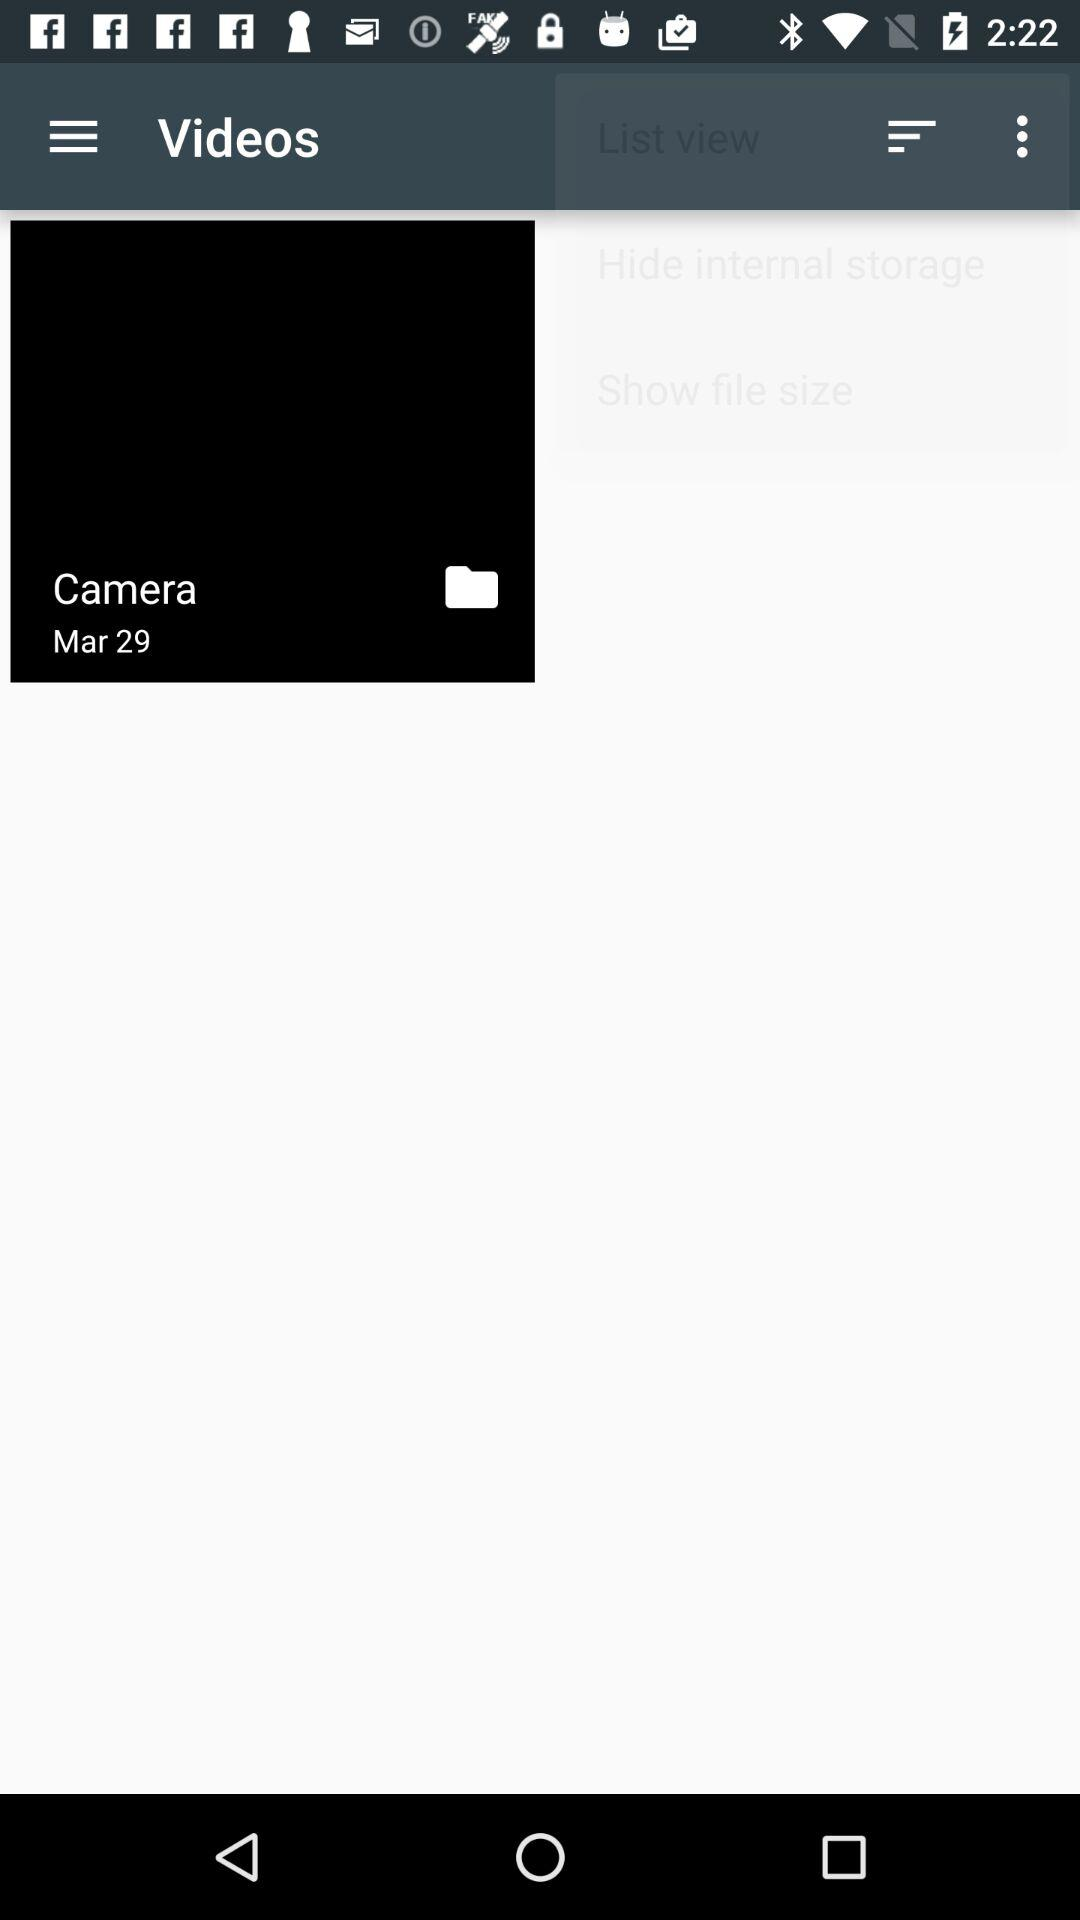What's the date of capture? The date of capture is March 29. 